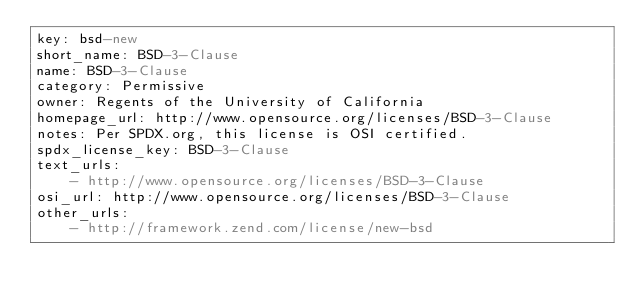Convert code to text. <code><loc_0><loc_0><loc_500><loc_500><_YAML_>key: bsd-new
short_name: BSD-3-Clause
name: BSD-3-Clause
category: Permissive
owner: Regents of the University of California
homepage_url: http://www.opensource.org/licenses/BSD-3-Clause
notes: Per SPDX.org, this license is OSI certified.
spdx_license_key: BSD-3-Clause
text_urls:
    - http://www.opensource.org/licenses/BSD-3-Clause
osi_url: http://www.opensource.org/licenses/BSD-3-Clause
other_urls:
    - http://framework.zend.com/license/new-bsd
</code> 